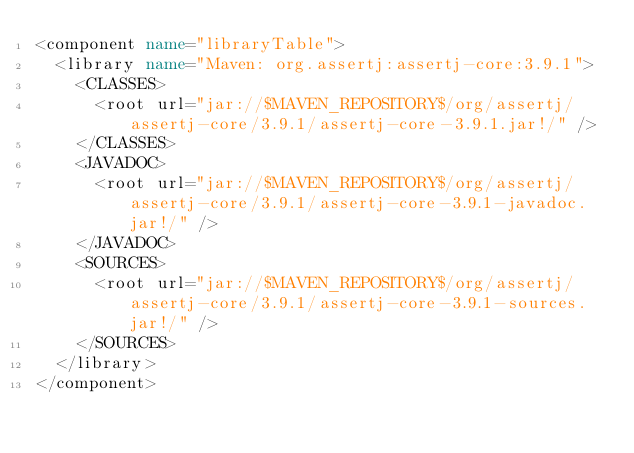Convert code to text. <code><loc_0><loc_0><loc_500><loc_500><_XML_><component name="libraryTable">
  <library name="Maven: org.assertj:assertj-core:3.9.1">
    <CLASSES>
      <root url="jar://$MAVEN_REPOSITORY$/org/assertj/assertj-core/3.9.1/assertj-core-3.9.1.jar!/" />
    </CLASSES>
    <JAVADOC>
      <root url="jar://$MAVEN_REPOSITORY$/org/assertj/assertj-core/3.9.1/assertj-core-3.9.1-javadoc.jar!/" />
    </JAVADOC>
    <SOURCES>
      <root url="jar://$MAVEN_REPOSITORY$/org/assertj/assertj-core/3.9.1/assertj-core-3.9.1-sources.jar!/" />
    </SOURCES>
  </library>
</component></code> 